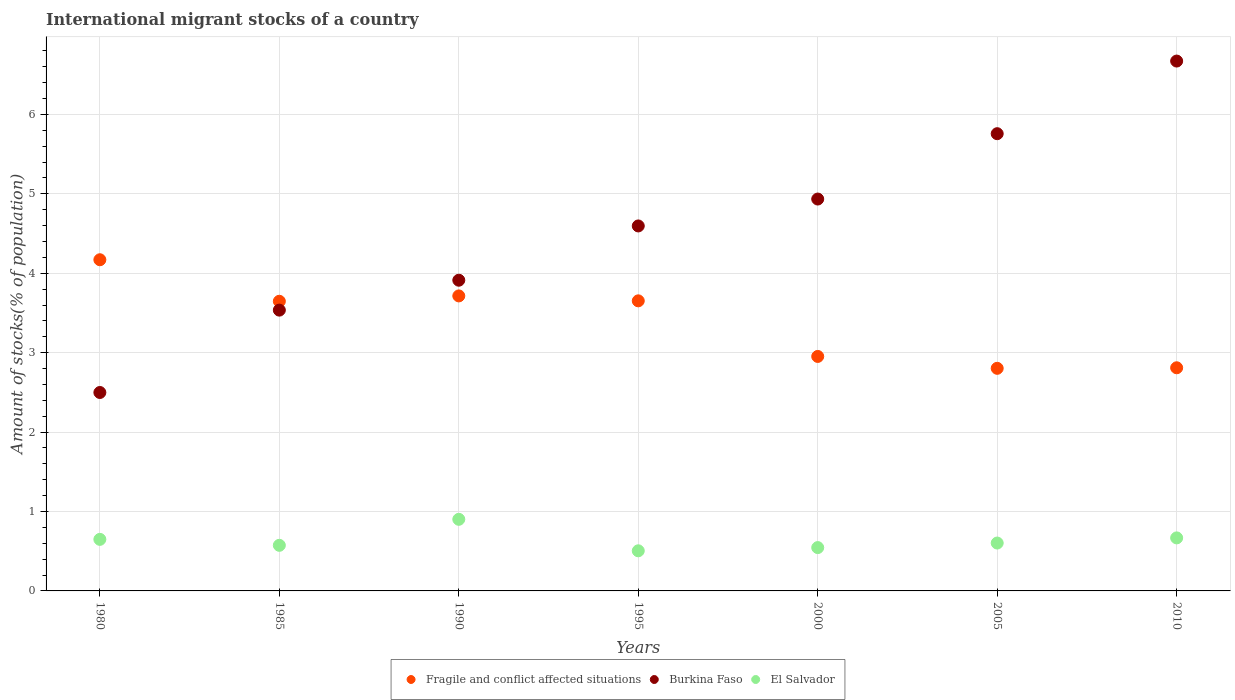Is the number of dotlines equal to the number of legend labels?
Give a very brief answer. Yes. What is the amount of stocks in in El Salvador in 1985?
Your response must be concise. 0.57. Across all years, what is the maximum amount of stocks in in El Salvador?
Your response must be concise. 0.9. Across all years, what is the minimum amount of stocks in in Burkina Faso?
Provide a succinct answer. 2.5. In which year was the amount of stocks in in Fragile and conflict affected situations maximum?
Provide a succinct answer. 1980. What is the total amount of stocks in in Burkina Faso in the graph?
Keep it short and to the point. 31.91. What is the difference between the amount of stocks in in Fragile and conflict affected situations in 1990 and that in 2010?
Your answer should be compact. 0.91. What is the difference between the amount of stocks in in Burkina Faso in 1995 and the amount of stocks in in Fragile and conflict affected situations in 2010?
Offer a terse response. 1.79. What is the average amount of stocks in in Fragile and conflict affected situations per year?
Offer a terse response. 3.39. In the year 2000, what is the difference between the amount of stocks in in El Salvador and amount of stocks in in Burkina Faso?
Ensure brevity in your answer.  -4.39. In how many years, is the amount of stocks in in El Salvador greater than 6.2 %?
Provide a succinct answer. 0. What is the ratio of the amount of stocks in in El Salvador in 1980 to that in 1995?
Keep it short and to the point. 1.28. What is the difference between the highest and the second highest amount of stocks in in Fragile and conflict affected situations?
Provide a short and direct response. 0.46. What is the difference between the highest and the lowest amount of stocks in in El Salvador?
Offer a terse response. 0.4. Is the sum of the amount of stocks in in Burkina Faso in 1995 and 2005 greater than the maximum amount of stocks in in El Salvador across all years?
Your answer should be compact. Yes. Does the amount of stocks in in El Salvador monotonically increase over the years?
Make the answer very short. No. Is the amount of stocks in in Burkina Faso strictly greater than the amount of stocks in in El Salvador over the years?
Keep it short and to the point. Yes. Does the graph contain grids?
Ensure brevity in your answer.  Yes. Where does the legend appear in the graph?
Give a very brief answer. Bottom center. How many legend labels are there?
Your answer should be compact. 3. How are the legend labels stacked?
Your answer should be very brief. Horizontal. What is the title of the graph?
Offer a very short reply. International migrant stocks of a country. What is the label or title of the Y-axis?
Provide a short and direct response. Amount of stocks(% of population). What is the Amount of stocks(% of population) of Fragile and conflict affected situations in 1980?
Your answer should be compact. 4.17. What is the Amount of stocks(% of population) of Burkina Faso in 1980?
Your answer should be compact. 2.5. What is the Amount of stocks(% of population) in El Salvador in 1980?
Make the answer very short. 0.65. What is the Amount of stocks(% of population) of Fragile and conflict affected situations in 1985?
Your answer should be compact. 3.65. What is the Amount of stocks(% of population) of Burkina Faso in 1985?
Provide a short and direct response. 3.54. What is the Amount of stocks(% of population) of El Salvador in 1985?
Make the answer very short. 0.57. What is the Amount of stocks(% of population) in Fragile and conflict affected situations in 1990?
Offer a very short reply. 3.72. What is the Amount of stocks(% of population) in Burkina Faso in 1990?
Your response must be concise. 3.91. What is the Amount of stocks(% of population) in El Salvador in 1990?
Offer a terse response. 0.9. What is the Amount of stocks(% of population) in Fragile and conflict affected situations in 1995?
Your answer should be very brief. 3.65. What is the Amount of stocks(% of population) of Burkina Faso in 1995?
Your response must be concise. 4.6. What is the Amount of stocks(% of population) in El Salvador in 1995?
Your answer should be compact. 0.51. What is the Amount of stocks(% of population) in Fragile and conflict affected situations in 2000?
Offer a very short reply. 2.95. What is the Amount of stocks(% of population) of Burkina Faso in 2000?
Your answer should be compact. 4.93. What is the Amount of stocks(% of population) in El Salvador in 2000?
Offer a terse response. 0.55. What is the Amount of stocks(% of population) in Fragile and conflict affected situations in 2005?
Your answer should be compact. 2.8. What is the Amount of stocks(% of population) in Burkina Faso in 2005?
Provide a succinct answer. 5.76. What is the Amount of stocks(% of population) in El Salvador in 2005?
Keep it short and to the point. 0.6. What is the Amount of stocks(% of population) in Fragile and conflict affected situations in 2010?
Ensure brevity in your answer.  2.81. What is the Amount of stocks(% of population) in Burkina Faso in 2010?
Give a very brief answer. 6.67. What is the Amount of stocks(% of population) of El Salvador in 2010?
Ensure brevity in your answer.  0.67. Across all years, what is the maximum Amount of stocks(% of population) in Fragile and conflict affected situations?
Your answer should be very brief. 4.17. Across all years, what is the maximum Amount of stocks(% of population) in Burkina Faso?
Your answer should be very brief. 6.67. Across all years, what is the maximum Amount of stocks(% of population) in El Salvador?
Give a very brief answer. 0.9. Across all years, what is the minimum Amount of stocks(% of population) of Fragile and conflict affected situations?
Ensure brevity in your answer.  2.8. Across all years, what is the minimum Amount of stocks(% of population) in Burkina Faso?
Provide a succinct answer. 2.5. Across all years, what is the minimum Amount of stocks(% of population) of El Salvador?
Ensure brevity in your answer.  0.51. What is the total Amount of stocks(% of population) in Fragile and conflict affected situations in the graph?
Your response must be concise. 23.75. What is the total Amount of stocks(% of population) in Burkina Faso in the graph?
Keep it short and to the point. 31.91. What is the total Amount of stocks(% of population) in El Salvador in the graph?
Your answer should be very brief. 4.45. What is the difference between the Amount of stocks(% of population) in Fragile and conflict affected situations in 1980 and that in 1985?
Your response must be concise. 0.52. What is the difference between the Amount of stocks(% of population) in Burkina Faso in 1980 and that in 1985?
Keep it short and to the point. -1.04. What is the difference between the Amount of stocks(% of population) in El Salvador in 1980 and that in 1985?
Give a very brief answer. 0.07. What is the difference between the Amount of stocks(% of population) of Fragile and conflict affected situations in 1980 and that in 1990?
Provide a short and direct response. 0.46. What is the difference between the Amount of stocks(% of population) in Burkina Faso in 1980 and that in 1990?
Keep it short and to the point. -1.41. What is the difference between the Amount of stocks(% of population) in El Salvador in 1980 and that in 1990?
Offer a very short reply. -0.25. What is the difference between the Amount of stocks(% of population) in Fragile and conflict affected situations in 1980 and that in 1995?
Provide a short and direct response. 0.52. What is the difference between the Amount of stocks(% of population) of Burkina Faso in 1980 and that in 1995?
Provide a short and direct response. -2.1. What is the difference between the Amount of stocks(% of population) in El Salvador in 1980 and that in 1995?
Ensure brevity in your answer.  0.14. What is the difference between the Amount of stocks(% of population) in Fragile and conflict affected situations in 1980 and that in 2000?
Your answer should be very brief. 1.22. What is the difference between the Amount of stocks(% of population) of Burkina Faso in 1980 and that in 2000?
Offer a terse response. -2.44. What is the difference between the Amount of stocks(% of population) in El Salvador in 1980 and that in 2000?
Provide a short and direct response. 0.1. What is the difference between the Amount of stocks(% of population) of Fragile and conflict affected situations in 1980 and that in 2005?
Your response must be concise. 1.37. What is the difference between the Amount of stocks(% of population) in Burkina Faso in 1980 and that in 2005?
Provide a short and direct response. -3.26. What is the difference between the Amount of stocks(% of population) of El Salvador in 1980 and that in 2005?
Offer a terse response. 0.05. What is the difference between the Amount of stocks(% of population) in Fragile and conflict affected situations in 1980 and that in 2010?
Offer a terse response. 1.36. What is the difference between the Amount of stocks(% of population) of Burkina Faso in 1980 and that in 2010?
Provide a succinct answer. -4.17. What is the difference between the Amount of stocks(% of population) in El Salvador in 1980 and that in 2010?
Give a very brief answer. -0.02. What is the difference between the Amount of stocks(% of population) of Fragile and conflict affected situations in 1985 and that in 1990?
Your response must be concise. -0.07. What is the difference between the Amount of stocks(% of population) of Burkina Faso in 1985 and that in 1990?
Provide a succinct answer. -0.38. What is the difference between the Amount of stocks(% of population) of El Salvador in 1985 and that in 1990?
Make the answer very short. -0.33. What is the difference between the Amount of stocks(% of population) in Fragile and conflict affected situations in 1985 and that in 1995?
Your answer should be very brief. -0.01. What is the difference between the Amount of stocks(% of population) of Burkina Faso in 1985 and that in 1995?
Offer a very short reply. -1.06. What is the difference between the Amount of stocks(% of population) in El Salvador in 1985 and that in 1995?
Your answer should be compact. 0.07. What is the difference between the Amount of stocks(% of population) of Fragile and conflict affected situations in 1985 and that in 2000?
Offer a terse response. 0.69. What is the difference between the Amount of stocks(% of population) of Burkina Faso in 1985 and that in 2000?
Your answer should be very brief. -1.4. What is the difference between the Amount of stocks(% of population) in El Salvador in 1985 and that in 2000?
Give a very brief answer. 0.03. What is the difference between the Amount of stocks(% of population) of Fragile and conflict affected situations in 1985 and that in 2005?
Keep it short and to the point. 0.84. What is the difference between the Amount of stocks(% of population) in Burkina Faso in 1985 and that in 2005?
Give a very brief answer. -2.22. What is the difference between the Amount of stocks(% of population) of El Salvador in 1985 and that in 2005?
Provide a short and direct response. -0.03. What is the difference between the Amount of stocks(% of population) of Fragile and conflict affected situations in 1985 and that in 2010?
Ensure brevity in your answer.  0.84. What is the difference between the Amount of stocks(% of population) of Burkina Faso in 1985 and that in 2010?
Your answer should be compact. -3.14. What is the difference between the Amount of stocks(% of population) in El Salvador in 1985 and that in 2010?
Provide a short and direct response. -0.09. What is the difference between the Amount of stocks(% of population) in Fragile and conflict affected situations in 1990 and that in 1995?
Provide a succinct answer. 0.06. What is the difference between the Amount of stocks(% of population) in Burkina Faso in 1990 and that in 1995?
Your response must be concise. -0.68. What is the difference between the Amount of stocks(% of population) in El Salvador in 1990 and that in 1995?
Offer a very short reply. 0.4. What is the difference between the Amount of stocks(% of population) of Fragile and conflict affected situations in 1990 and that in 2000?
Your answer should be compact. 0.76. What is the difference between the Amount of stocks(% of population) in Burkina Faso in 1990 and that in 2000?
Offer a very short reply. -1.02. What is the difference between the Amount of stocks(% of population) of El Salvador in 1990 and that in 2000?
Your answer should be very brief. 0.36. What is the difference between the Amount of stocks(% of population) of Fragile and conflict affected situations in 1990 and that in 2005?
Ensure brevity in your answer.  0.91. What is the difference between the Amount of stocks(% of population) of Burkina Faso in 1990 and that in 2005?
Provide a short and direct response. -1.85. What is the difference between the Amount of stocks(% of population) of El Salvador in 1990 and that in 2005?
Ensure brevity in your answer.  0.3. What is the difference between the Amount of stocks(% of population) in Fragile and conflict affected situations in 1990 and that in 2010?
Provide a short and direct response. 0.91. What is the difference between the Amount of stocks(% of population) of Burkina Faso in 1990 and that in 2010?
Offer a very short reply. -2.76. What is the difference between the Amount of stocks(% of population) in El Salvador in 1990 and that in 2010?
Keep it short and to the point. 0.23. What is the difference between the Amount of stocks(% of population) of Fragile and conflict affected situations in 1995 and that in 2000?
Give a very brief answer. 0.7. What is the difference between the Amount of stocks(% of population) of Burkina Faso in 1995 and that in 2000?
Keep it short and to the point. -0.34. What is the difference between the Amount of stocks(% of population) in El Salvador in 1995 and that in 2000?
Offer a very short reply. -0.04. What is the difference between the Amount of stocks(% of population) in Fragile and conflict affected situations in 1995 and that in 2005?
Provide a succinct answer. 0.85. What is the difference between the Amount of stocks(% of population) in Burkina Faso in 1995 and that in 2005?
Ensure brevity in your answer.  -1.16. What is the difference between the Amount of stocks(% of population) in El Salvador in 1995 and that in 2005?
Offer a terse response. -0.1. What is the difference between the Amount of stocks(% of population) in Fragile and conflict affected situations in 1995 and that in 2010?
Keep it short and to the point. 0.84. What is the difference between the Amount of stocks(% of population) of Burkina Faso in 1995 and that in 2010?
Keep it short and to the point. -2.08. What is the difference between the Amount of stocks(% of population) in El Salvador in 1995 and that in 2010?
Your response must be concise. -0.16. What is the difference between the Amount of stocks(% of population) in Fragile and conflict affected situations in 2000 and that in 2005?
Your answer should be compact. 0.15. What is the difference between the Amount of stocks(% of population) in Burkina Faso in 2000 and that in 2005?
Provide a short and direct response. -0.82. What is the difference between the Amount of stocks(% of population) of El Salvador in 2000 and that in 2005?
Provide a succinct answer. -0.06. What is the difference between the Amount of stocks(% of population) in Fragile and conflict affected situations in 2000 and that in 2010?
Make the answer very short. 0.14. What is the difference between the Amount of stocks(% of population) of Burkina Faso in 2000 and that in 2010?
Provide a succinct answer. -1.74. What is the difference between the Amount of stocks(% of population) in El Salvador in 2000 and that in 2010?
Keep it short and to the point. -0.12. What is the difference between the Amount of stocks(% of population) of Fragile and conflict affected situations in 2005 and that in 2010?
Your answer should be compact. -0.01. What is the difference between the Amount of stocks(% of population) in Burkina Faso in 2005 and that in 2010?
Your response must be concise. -0.91. What is the difference between the Amount of stocks(% of population) of El Salvador in 2005 and that in 2010?
Make the answer very short. -0.06. What is the difference between the Amount of stocks(% of population) in Fragile and conflict affected situations in 1980 and the Amount of stocks(% of population) in Burkina Faso in 1985?
Give a very brief answer. 0.63. What is the difference between the Amount of stocks(% of population) in Fragile and conflict affected situations in 1980 and the Amount of stocks(% of population) in El Salvador in 1985?
Your answer should be very brief. 3.6. What is the difference between the Amount of stocks(% of population) in Burkina Faso in 1980 and the Amount of stocks(% of population) in El Salvador in 1985?
Provide a succinct answer. 1.92. What is the difference between the Amount of stocks(% of population) in Fragile and conflict affected situations in 1980 and the Amount of stocks(% of population) in Burkina Faso in 1990?
Make the answer very short. 0.26. What is the difference between the Amount of stocks(% of population) in Fragile and conflict affected situations in 1980 and the Amount of stocks(% of population) in El Salvador in 1990?
Your response must be concise. 3.27. What is the difference between the Amount of stocks(% of population) of Burkina Faso in 1980 and the Amount of stocks(% of population) of El Salvador in 1990?
Your answer should be very brief. 1.6. What is the difference between the Amount of stocks(% of population) in Fragile and conflict affected situations in 1980 and the Amount of stocks(% of population) in Burkina Faso in 1995?
Your answer should be very brief. -0.43. What is the difference between the Amount of stocks(% of population) in Fragile and conflict affected situations in 1980 and the Amount of stocks(% of population) in El Salvador in 1995?
Make the answer very short. 3.67. What is the difference between the Amount of stocks(% of population) in Burkina Faso in 1980 and the Amount of stocks(% of population) in El Salvador in 1995?
Provide a succinct answer. 1.99. What is the difference between the Amount of stocks(% of population) of Fragile and conflict affected situations in 1980 and the Amount of stocks(% of population) of Burkina Faso in 2000?
Your answer should be very brief. -0.76. What is the difference between the Amount of stocks(% of population) in Fragile and conflict affected situations in 1980 and the Amount of stocks(% of population) in El Salvador in 2000?
Ensure brevity in your answer.  3.62. What is the difference between the Amount of stocks(% of population) in Burkina Faso in 1980 and the Amount of stocks(% of population) in El Salvador in 2000?
Offer a terse response. 1.95. What is the difference between the Amount of stocks(% of population) in Fragile and conflict affected situations in 1980 and the Amount of stocks(% of population) in Burkina Faso in 2005?
Provide a short and direct response. -1.59. What is the difference between the Amount of stocks(% of population) of Fragile and conflict affected situations in 1980 and the Amount of stocks(% of population) of El Salvador in 2005?
Your answer should be compact. 3.57. What is the difference between the Amount of stocks(% of population) in Burkina Faso in 1980 and the Amount of stocks(% of population) in El Salvador in 2005?
Your response must be concise. 1.9. What is the difference between the Amount of stocks(% of population) in Fragile and conflict affected situations in 1980 and the Amount of stocks(% of population) in Burkina Faso in 2010?
Provide a succinct answer. -2.5. What is the difference between the Amount of stocks(% of population) in Fragile and conflict affected situations in 1980 and the Amount of stocks(% of population) in El Salvador in 2010?
Ensure brevity in your answer.  3.5. What is the difference between the Amount of stocks(% of population) of Burkina Faso in 1980 and the Amount of stocks(% of population) of El Salvador in 2010?
Keep it short and to the point. 1.83. What is the difference between the Amount of stocks(% of population) of Fragile and conflict affected situations in 1985 and the Amount of stocks(% of population) of Burkina Faso in 1990?
Your answer should be very brief. -0.27. What is the difference between the Amount of stocks(% of population) in Fragile and conflict affected situations in 1985 and the Amount of stocks(% of population) in El Salvador in 1990?
Your answer should be very brief. 2.75. What is the difference between the Amount of stocks(% of population) of Burkina Faso in 1985 and the Amount of stocks(% of population) of El Salvador in 1990?
Provide a succinct answer. 2.63. What is the difference between the Amount of stocks(% of population) in Fragile and conflict affected situations in 1985 and the Amount of stocks(% of population) in Burkina Faso in 1995?
Your answer should be very brief. -0.95. What is the difference between the Amount of stocks(% of population) in Fragile and conflict affected situations in 1985 and the Amount of stocks(% of population) in El Salvador in 1995?
Your response must be concise. 3.14. What is the difference between the Amount of stocks(% of population) of Burkina Faso in 1985 and the Amount of stocks(% of population) of El Salvador in 1995?
Your response must be concise. 3.03. What is the difference between the Amount of stocks(% of population) of Fragile and conflict affected situations in 1985 and the Amount of stocks(% of population) of Burkina Faso in 2000?
Your answer should be very brief. -1.29. What is the difference between the Amount of stocks(% of population) of Fragile and conflict affected situations in 1985 and the Amount of stocks(% of population) of El Salvador in 2000?
Your answer should be very brief. 3.1. What is the difference between the Amount of stocks(% of population) of Burkina Faso in 1985 and the Amount of stocks(% of population) of El Salvador in 2000?
Give a very brief answer. 2.99. What is the difference between the Amount of stocks(% of population) in Fragile and conflict affected situations in 1985 and the Amount of stocks(% of population) in Burkina Faso in 2005?
Provide a succinct answer. -2.11. What is the difference between the Amount of stocks(% of population) of Fragile and conflict affected situations in 1985 and the Amount of stocks(% of population) of El Salvador in 2005?
Give a very brief answer. 3.04. What is the difference between the Amount of stocks(% of population) of Burkina Faso in 1985 and the Amount of stocks(% of population) of El Salvador in 2005?
Offer a very short reply. 2.93. What is the difference between the Amount of stocks(% of population) in Fragile and conflict affected situations in 1985 and the Amount of stocks(% of population) in Burkina Faso in 2010?
Your answer should be very brief. -3.02. What is the difference between the Amount of stocks(% of population) in Fragile and conflict affected situations in 1985 and the Amount of stocks(% of population) in El Salvador in 2010?
Provide a succinct answer. 2.98. What is the difference between the Amount of stocks(% of population) of Burkina Faso in 1985 and the Amount of stocks(% of population) of El Salvador in 2010?
Keep it short and to the point. 2.87. What is the difference between the Amount of stocks(% of population) of Fragile and conflict affected situations in 1990 and the Amount of stocks(% of population) of Burkina Faso in 1995?
Offer a terse response. -0.88. What is the difference between the Amount of stocks(% of population) of Fragile and conflict affected situations in 1990 and the Amount of stocks(% of population) of El Salvador in 1995?
Make the answer very short. 3.21. What is the difference between the Amount of stocks(% of population) in Burkina Faso in 1990 and the Amount of stocks(% of population) in El Salvador in 1995?
Offer a terse response. 3.41. What is the difference between the Amount of stocks(% of population) of Fragile and conflict affected situations in 1990 and the Amount of stocks(% of population) of Burkina Faso in 2000?
Your response must be concise. -1.22. What is the difference between the Amount of stocks(% of population) in Fragile and conflict affected situations in 1990 and the Amount of stocks(% of population) in El Salvador in 2000?
Make the answer very short. 3.17. What is the difference between the Amount of stocks(% of population) in Burkina Faso in 1990 and the Amount of stocks(% of population) in El Salvador in 2000?
Provide a short and direct response. 3.37. What is the difference between the Amount of stocks(% of population) of Fragile and conflict affected situations in 1990 and the Amount of stocks(% of population) of Burkina Faso in 2005?
Offer a very short reply. -2.04. What is the difference between the Amount of stocks(% of population) of Fragile and conflict affected situations in 1990 and the Amount of stocks(% of population) of El Salvador in 2005?
Your response must be concise. 3.11. What is the difference between the Amount of stocks(% of population) in Burkina Faso in 1990 and the Amount of stocks(% of population) in El Salvador in 2005?
Ensure brevity in your answer.  3.31. What is the difference between the Amount of stocks(% of population) of Fragile and conflict affected situations in 1990 and the Amount of stocks(% of population) of Burkina Faso in 2010?
Your answer should be very brief. -2.96. What is the difference between the Amount of stocks(% of population) in Fragile and conflict affected situations in 1990 and the Amount of stocks(% of population) in El Salvador in 2010?
Offer a very short reply. 3.05. What is the difference between the Amount of stocks(% of population) of Burkina Faso in 1990 and the Amount of stocks(% of population) of El Salvador in 2010?
Make the answer very short. 3.24. What is the difference between the Amount of stocks(% of population) in Fragile and conflict affected situations in 1995 and the Amount of stocks(% of population) in Burkina Faso in 2000?
Make the answer very short. -1.28. What is the difference between the Amount of stocks(% of population) of Fragile and conflict affected situations in 1995 and the Amount of stocks(% of population) of El Salvador in 2000?
Your answer should be very brief. 3.11. What is the difference between the Amount of stocks(% of population) in Burkina Faso in 1995 and the Amount of stocks(% of population) in El Salvador in 2000?
Ensure brevity in your answer.  4.05. What is the difference between the Amount of stocks(% of population) of Fragile and conflict affected situations in 1995 and the Amount of stocks(% of population) of Burkina Faso in 2005?
Provide a succinct answer. -2.1. What is the difference between the Amount of stocks(% of population) in Fragile and conflict affected situations in 1995 and the Amount of stocks(% of population) in El Salvador in 2005?
Keep it short and to the point. 3.05. What is the difference between the Amount of stocks(% of population) of Burkina Faso in 1995 and the Amount of stocks(% of population) of El Salvador in 2005?
Provide a short and direct response. 3.99. What is the difference between the Amount of stocks(% of population) in Fragile and conflict affected situations in 1995 and the Amount of stocks(% of population) in Burkina Faso in 2010?
Ensure brevity in your answer.  -3.02. What is the difference between the Amount of stocks(% of population) of Fragile and conflict affected situations in 1995 and the Amount of stocks(% of population) of El Salvador in 2010?
Keep it short and to the point. 2.99. What is the difference between the Amount of stocks(% of population) of Burkina Faso in 1995 and the Amount of stocks(% of population) of El Salvador in 2010?
Make the answer very short. 3.93. What is the difference between the Amount of stocks(% of population) in Fragile and conflict affected situations in 2000 and the Amount of stocks(% of population) in Burkina Faso in 2005?
Your answer should be very brief. -2.81. What is the difference between the Amount of stocks(% of population) in Fragile and conflict affected situations in 2000 and the Amount of stocks(% of population) in El Salvador in 2005?
Provide a succinct answer. 2.35. What is the difference between the Amount of stocks(% of population) in Burkina Faso in 2000 and the Amount of stocks(% of population) in El Salvador in 2005?
Offer a terse response. 4.33. What is the difference between the Amount of stocks(% of population) in Fragile and conflict affected situations in 2000 and the Amount of stocks(% of population) in Burkina Faso in 2010?
Ensure brevity in your answer.  -3.72. What is the difference between the Amount of stocks(% of population) of Fragile and conflict affected situations in 2000 and the Amount of stocks(% of population) of El Salvador in 2010?
Keep it short and to the point. 2.29. What is the difference between the Amount of stocks(% of population) of Burkina Faso in 2000 and the Amount of stocks(% of population) of El Salvador in 2010?
Ensure brevity in your answer.  4.27. What is the difference between the Amount of stocks(% of population) of Fragile and conflict affected situations in 2005 and the Amount of stocks(% of population) of Burkina Faso in 2010?
Make the answer very short. -3.87. What is the difference between the Amount of stocks(% of population) in Fragile and conflict affected situations in 2005 and the Amount of stocks(% of population) in El Salvador in 2010?
Give a very brief answer. 2.14. What is the difference between the Amount of stocks(% of population) of Burkina Faso in 2005 and the Amount of stocks(% of population) of El Salvador in 2010?
Your answer should be very brief. 5.09. What is the average Amount of stocks(% of population) in Fragile and conflict affected situations per year?
Ensure brevity in your answer.  3.39. What is the average Amount of stocks(% of population) of Burkina Faso per year?
Offer a terse response. 4.56. What is the average Amount of stocks(% of population) of El Salvador per year?
Offer a terse response. 0.64. In the year 1980, what is the difference between the Amount of stocks(% of population) of Fragile and conflict affected situations and Amount of stocks(% of population) of Burkina Faso?
Ensure brevity in your answer.  1.67. In the year 1980, what is the difference between the Amount of stocks(% of population) of Fragile and conflict affected situations and Amount of stocks(% of population) of El Salvador?
Offer a very short reply. 3.52. In the year 1980, what is the difference between the Amount of stocks(% of population) in Burkina Faso and Amount of stocks(% of population) in El Salvador?
Keep it short and to the point. 1.85. In the year 1985, what is the difference between the Amount of stocks(% of population) of Fragile and conflict affected situations and Amount of stocks(% of population) of Burkina Faso?
Your response must be concise. 0.11. In the year 1985, what is the difference between the Amount of stocks(% of population) of Fragile and conflict affected situations and Amount of stocks(% of population) of El Salvador?
Offer a terse response. 3.07. In the year 1985, what is the difference between the Amount of stocks(% of population) in Burkina Faso and Amount of stocks(% of population) in El Salvador?
Ensure brevity in your answer.  2.96. In the year 1990, what is the difference between the Amount of stocks(% of population) in Fragile and conflict affected situations and Amount of stocks(% of population) in Burkina Faso?
Give a very brief answer. -0.2. In the year 1990, what is the difference between the Amount of stocks(% of population) in Fragile and conflict affected situations and Amount of stocks(% of population) in El Salvador?
Your answer should be compact. 2.81. In the year 1990, what is the difference between the Amount of stocks(% of population) in Burkina Faso and Amount of stocks(% of population) in El Salvador?
Make the answer very short. 3.01. In the year 1995, what is the difference between the Amount of stocks(% of population) in Fragile and conflict affected situations and Amount of stocks(% of population) in Burkina Faso?
Provide a succinct answer. -0.94. In the year 1995, what is the difference between the Amount of stocks(% of population) in Fragile and conflict affected situations and Amount of stocks(% of population) in El Salvador?
Keep it short and to the point. 3.15. In the year 1995, what is the difference between the Amount of stocks(% of population) of Burkina Faso and Amount of stocks(% of population) of El Salvador?
Make the answer very short. 4.09. In the year 2000, what is the difference between the Amount of stocks(% of population) in Fragile and conflict affected situations and Amount of stocks(% of population) in Burkina Faso?
Offer a terse response. -1.98. In the year 2000, what is the difference between the Amount of stocks(% of population) of Fragile and conflict affected situations and Amount of stocks(% of population) of El Salvador?
Ensure brevity in your answer.  2.41. In the year 2000, what is the difference between the Amount of stocks(% of population) of Burkina Faso and Amount of stocks(% of population) of El Salvador?
Your answer should be very brief. 4.39. In the year 2005, what is the difference between the Amount of stocks(% of population) of Fragile and conflict affected situations and Amount of stocks(% of population) of Burkina Faso?
Your answer should be very brief. -2.95. In the year 2005, what is the difference between the Amount of stocks(% of population) of Fragile and conflict affected situations and Amount of stocks(% of population) of El Salvador?
Ensure brevity in your answer.  2.2. In the year 2005, what is the difference between the Amount of stocks(% of population) of Burkina Faso and Amount of stocks(% of population) of El Salvador?
Your answer should be very brief. 5.15. In the year 2010, what is the difference between the Amount of stocks(% of population) of Fragile and conflict affected situations and Amount of stocks(% of population) of Burkina Faso?
Provide a succinct answer. -3.86. In the year 2010, what is the difference between the Amount of stocks(% of population) in Fragile and conflict affected situations and Amount of stocks(% of population) in El Salvador?
Give a very brief answer. 2.14. In the year 2010, what is the difference between the Amount of stocks(% of population) of Burkina Faso and Amount of stocks(% of population) of El Salvador?
Keep it short and to the point. 6. What is the ratio of the Amount of stocks(% of population) of Fragile and conflict affected situations in 1980 to that in 1985?
Your answer should be compact. 1.14. What is the ratio of the Amount of stocks(% of population) of Burkina Faso in 1980 to that in 1985?
Provide a short and direct response. 0.71. What is the ratio of the Amount of stocks(% of population) in El Salvador in 1980 to that in 1985?
Keep it short and to the point. 1.13. What is the ratio of the Amount of stocks(% of population) in Fragile and conflict affected situations in 1980 to that in 1990?
Provide a succinct answer. 1.12. What is the ratio of the Amount of stocks(% of population) in Burkina Faso in 1980 to that in 1990?
Provide a short and direct response. 0.64. What is the ratio of the Amount of stocks(% of population) of El Salvador in 1980 to that in 1990?
Your response must be concise. 0.72. What is the ratio of the Amount of stocks(% of population) in Fragile and conflict affected situations in 1980 to that in 1995?
Provide a succinct answer. 1.14. What is the ratio of the Amount of stocks(% of population) in Burkina Faso in 1980 to that in 1995?
Your response must be concise. 0.54. What is the ratio of the Amount of stocks(% of population) of El Salvador in 1980 to that in 1995?
Make the answer very short. 1.28. What is the ratio of the Amount of stocks(% of population) of Fragile and conflict affected situations in 1980 to that in 2000?
Ensure brevity in your answer.  1.41. What is the ratio of the Amount of stocks(% of population) in Burkina Faso in 1980 to that in 2000?
Your answer should be compact. 0.51. What is the ratio of the Amount of stocks(% of population) of El Salvador in 1980 to that in 2000?
Give a very brief answer. 1.19. What is the ratio of the Amount of stocks(% of population) of Fragile and conflict affected situations in 1980 to that in 2005?
Give a very brief answer. 1.49. What is the ratio of the Amount of stocks(% of population) in Burkina Faso in 1980 to that in 2005?
Your response must be concise. 0.43. What is the ratio of the Amount of stocks(% of population) of El Salvador in 1980 to that in 2005?
Your response must be concise. 1.08. What is the ratio of the Amount of stocks(% of population) of Fragile and conflict affected situations in 1980 to that in 2010?
Keep it short and to the point. 1.48. What is the ratio of the Amount of stocks(% of population) in Burkina Faso in 1980 to that in 2010?
Offer a terse response. 0.37. What is the ratio of the Amount of stocks(% of population) in El Salvador in 1980 to that in 2010?
Your response must be concise. 0.97. What is the ratio of the Amount of stocks(% of population) in Fragile and conflict affected situations in 1985 to that in 1990?
Give a very brief answer. 0.98. What is the ratio of the Amount of stocks(% of population) in Burkina Faso in 1985 to that in 1990?
Provide a succinct answer. 0.9. What is the ratio of the Amount of stocks(% of population) of El Salvador in 1985 to that in 1990?
Your answer should be very brief. 0.64. What is the ratio of the Amount of stocks(% of population) of Fragile and conflict affected situations in 1985 to that in 1995?
Offer a terse response. 1. What is the ratio of the Amount of stocks(% of population) in Burkina Faso in 1985 to that in 1995?
Give a very brief answer. 0.77. What is the ratio of the Amount of stocks(% of population) of El Salvador in 1985 to that in 1995?
Your response must be concise. 1.14. What is the ratio of the Amount of stocks(% of population) in Fragile and conflict affected situations in 1985 to that in 2000?
Give a very brief answer. 1.24. What is the ratio of the Amount of stocks(% of population) of Burkina Faso in 1985 to that in 2000?
Your response must be concise. 0.72. What is the ratio of the Amount of stocks(% of population) in El Salvador in 1985 to that in 2000?
Your answer should be very brief. 1.05. What is the ratio of the Amount of stocks(% of population) in Fragile and conflict affected situations in 1985 to that in 2005?
Your response must be concise. 1.3. What is the ratio of the Amount of stocks(% of population) of Burkina Faso in 1985 to that in 2005?
Offer a very short reply. 0.61. What is the ratio of the Amount of stocks(% of population) in El Salvador in 1985 to that in 2005?
Provide a succinct answer. 0.95. What is the ratio of the Amount of stocks(% of population) in Fragile and conflict affected situations in 1985 to that in 2010?
Your response must be concise. 1.3. What is the ratio of the Amount of stocks(% of population) in Burkina Faso in 1985 to that in 2010?
Provide a succinct answer. 0.53. What is the ratio of the Amount of stocks(% of population) of El Salvador in 1985 to that in 2010?
Make the answer very short. 0.86. What is the ratio of the Amount of stocks(% of population) in Burkina Faso in 1990 to that in 1995?
Ensure brevity in your answer.  0.85. What is the ratio of the Amount of stocks(% of population) of El Salvador in 1990 to that in 1995?
Your answer should be very brief. 1.78. What is the ratio of the Amount of stocks(% of population) in Fragile and conflict affected situations in 1990 to that in 2000?
Your answer should be very brief. 1.26. What is the ratio of the Amount of stocks(% of population) of Burkina Faso in 1990 to that in 2000?
Your answer should be very brief. 0.79. What is the ratio of the Amount of stocks(% of population) in El Salvador in 1990 to that in 2000?
Your answer should be compact. 1.65. What is the ratio of the Amount of stocks(% of population) of Fragile and conflict affected situations in 1990 to that in 2005?
Provide a succinct answer. 1.33. What is the ratio of the Amount of stocks(% of population) in Burkina Faso in 1990 to that in 2005?
Your answer should be very brief. 0.68. What is the ratio of the Amount of stocks(% of population) in El Salvador in 1990 to that in 2005?
Offer a terse response. 1.5. What is the ratio of the Amount of stocks(% of population) in Fragile and conflict affected situations in 1990 to that in 2010?
Offer a very short reply. 1.32. What is the ratio of the Amount of stocks(% of population) of Burkina Faso in 1990 to that in 2010?
Give a very brief answer. 0.59. What is the ratio of the Amount of stocks(% of population) in El Salvador in 1990 to that in 2010?
Your answer should be compact. 1.35. What is the ratio of the Amount of stocks(% of population) of Fragile and conflict affected situations in 1995 to that in 2000?
Your answer should be very brief. 1.24. What is the ratio of the Amount of stocks(% of population) of Burkina Faso in 1995 to that in 2000?
Your response must be concise. 0.93. What is the ratio of the Amount of stocks(% of population) of El Salvador in 1995 to that in 2000?
Your answer should be very brief. 0.93. What is the ratio of the Amount of stocks(% of population) of Fragile and conflict affected situations in 1995 to that in 2005?
Provide a short and direct response. 1.3. What is the ratio of the Amount of stocks(% of population) in Burkina Faso in 1995 to that in 2005?
Your answer should be compact. 0.8. What is the ratio of the Amount of stocks(% of population) of El Salvador in 1995 to that in 2005?
Your answer should be compact. 0.84. What is the ratio of the Amount of stocks(% of population) in Burkina Faso in 1995 to that in 2010?
Your answer should be very brief. 0.69. What is the ratio of the Amount of stocks(% of population) in El Salvador in 1995 to that in 2010?
Offer a very short reply. 0.76. What is the ratio of the Amount of stocks(% of population) in Fragile and conflict affected situations in 2000 to that in 2005?
Your answer should be very brief. 1.05. What is the ratio of the Amount of stocks(% of population) of El Salvador in 2000 to that in 2005?
Provide a succinct answer. 0.9. What is the ratio of the Amount of stocks(% of population) in Fragile and conflict affected situations in 2000 to that in 2010?
Offer a terse response. 1.05. What is the ratio of the Amount of stocks(% of population) of Burkina Faso in 2000 to that in 2010?
Provide a succinct answer. 0.74. What is the ratio of the Amount of stocks(% of population) of El Salvador in 2000 to that in 2010?
Keep it short and to the point. 0.82. What is the ratio of the Amount of stocks(% of population) in Fragile and conflict affected situations in 2005 to that in 2010?
Offer a very short reply. 1. What is the ratio of the Amount of stocks(% of population) of Burkina Faso in 2005 to that in 2010?
Your answer should be compact. 0.86. What is the ratio of the Amount of stocks(% of population) in El Salvador in 2005 to that in 2010?
Offer a very short reply. 0.9. What is the difference between the highest and the second highest Amount of stocks(% of population) in Fragile and conflict affected situations?
Make the answer very short. 0.46. What is the difference between the highest and the second highest Amount of stocks(% of population) of Burkina Faso?
Offer a very short reply. 0.91. What is the difference between the highest and the second highest Amount of stocks(% of population) of El Salvador?
Give a very brief answer. 0.23. What is the difference between the highest and the lowest Amount of stocks(% of population) of Fragile and conflict affected situations?
Offer a terse response. 1.37. What is the difference between the highest and the lowest Amount of stocks(% of population) in Burkina Faso?
Make the answer very short. 4.17. What is the difference between the highest and the lowest Amount of stocks(% of population) of El Salvador?
Give a very brief answer. 0.4. 